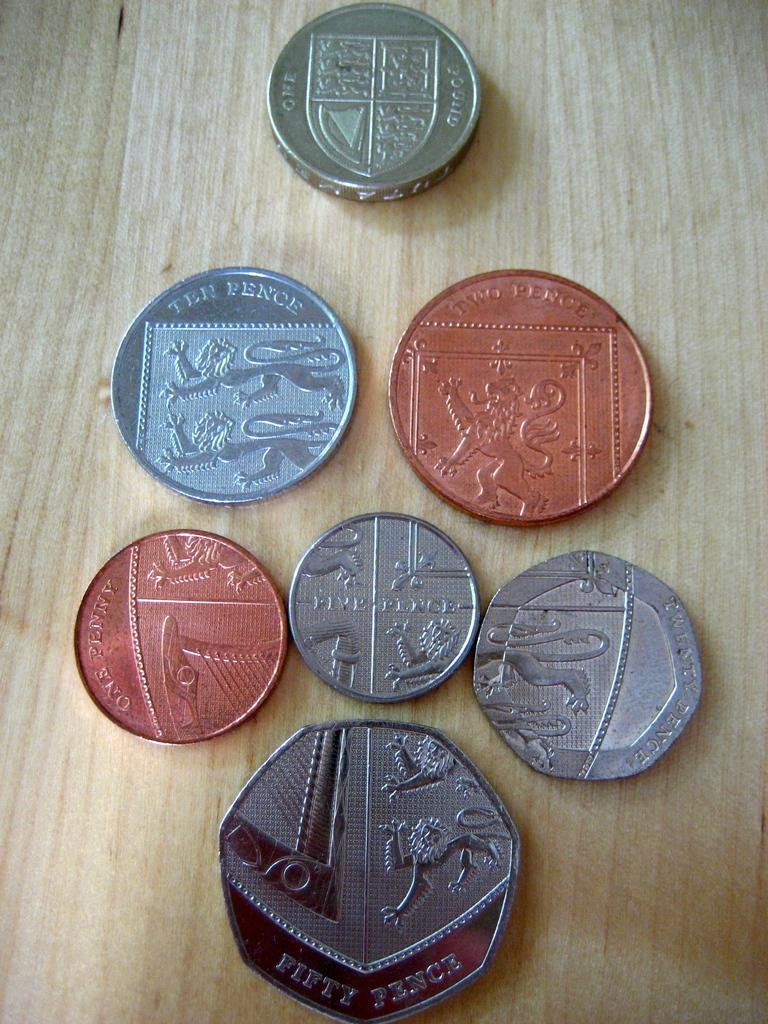<image>
Create a compact narrative representing the image presented. A fifty pence coin is below other coins on a wood surface. 